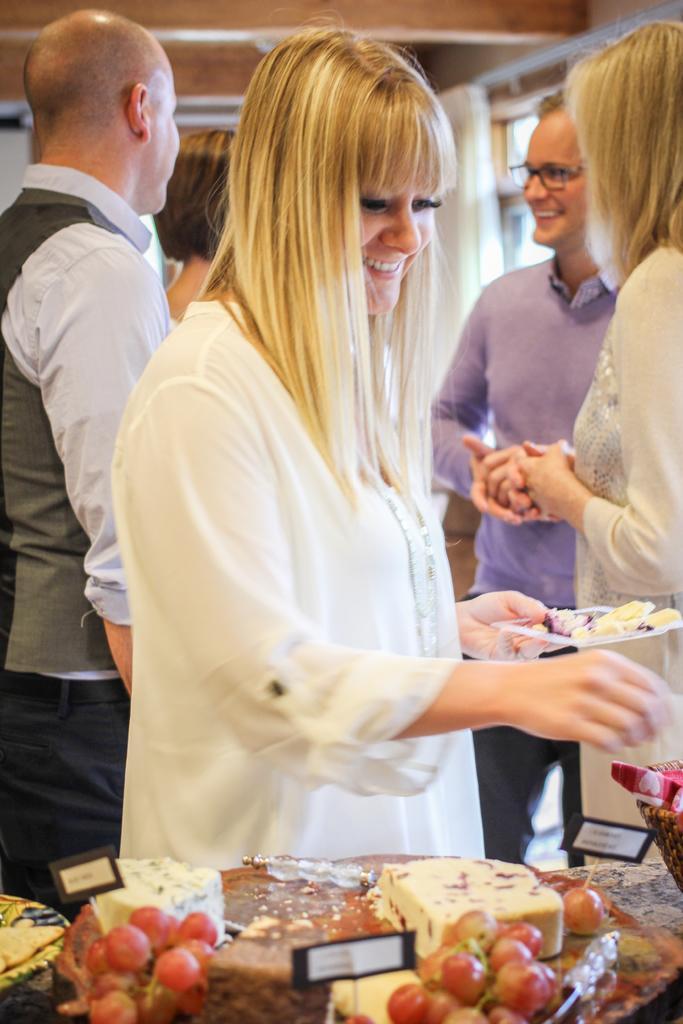Could you give a brief overview of what you see in this image? In this image there is a woman holding a plate in her hand is having a smile on her face, in front of the woman there are a few food items with labels, behind the woman there are few other people standing. 